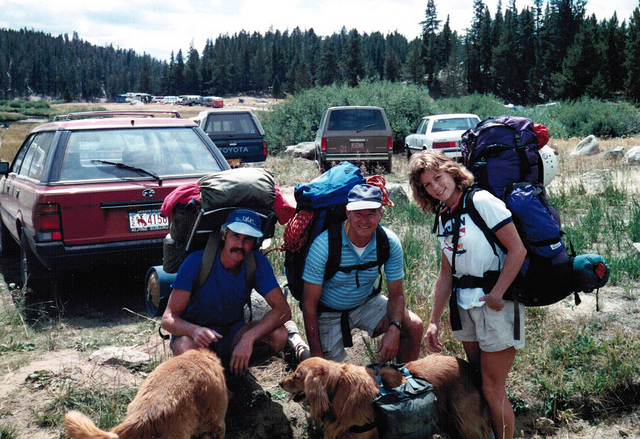Identify and read out the text in this image. TOYOTA 4158 